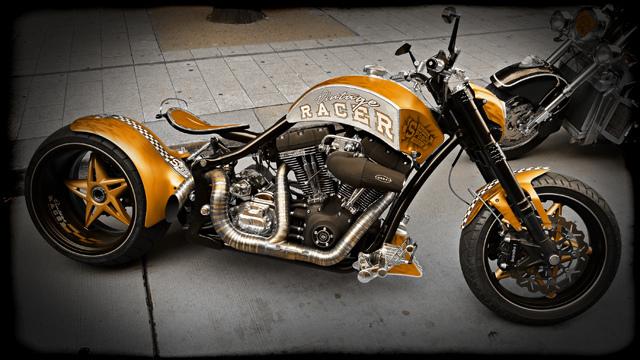Has this motorcycle been painted?
Be succinct. Yes. How many wheels are in the picture?
Give a very brief answer. 3. Do the spokes match the frame?
Be succinct. Yes. What is the yellow object?
Be succinct. Motorcycle. What does the bike say?
Quick response, please. Racer. 